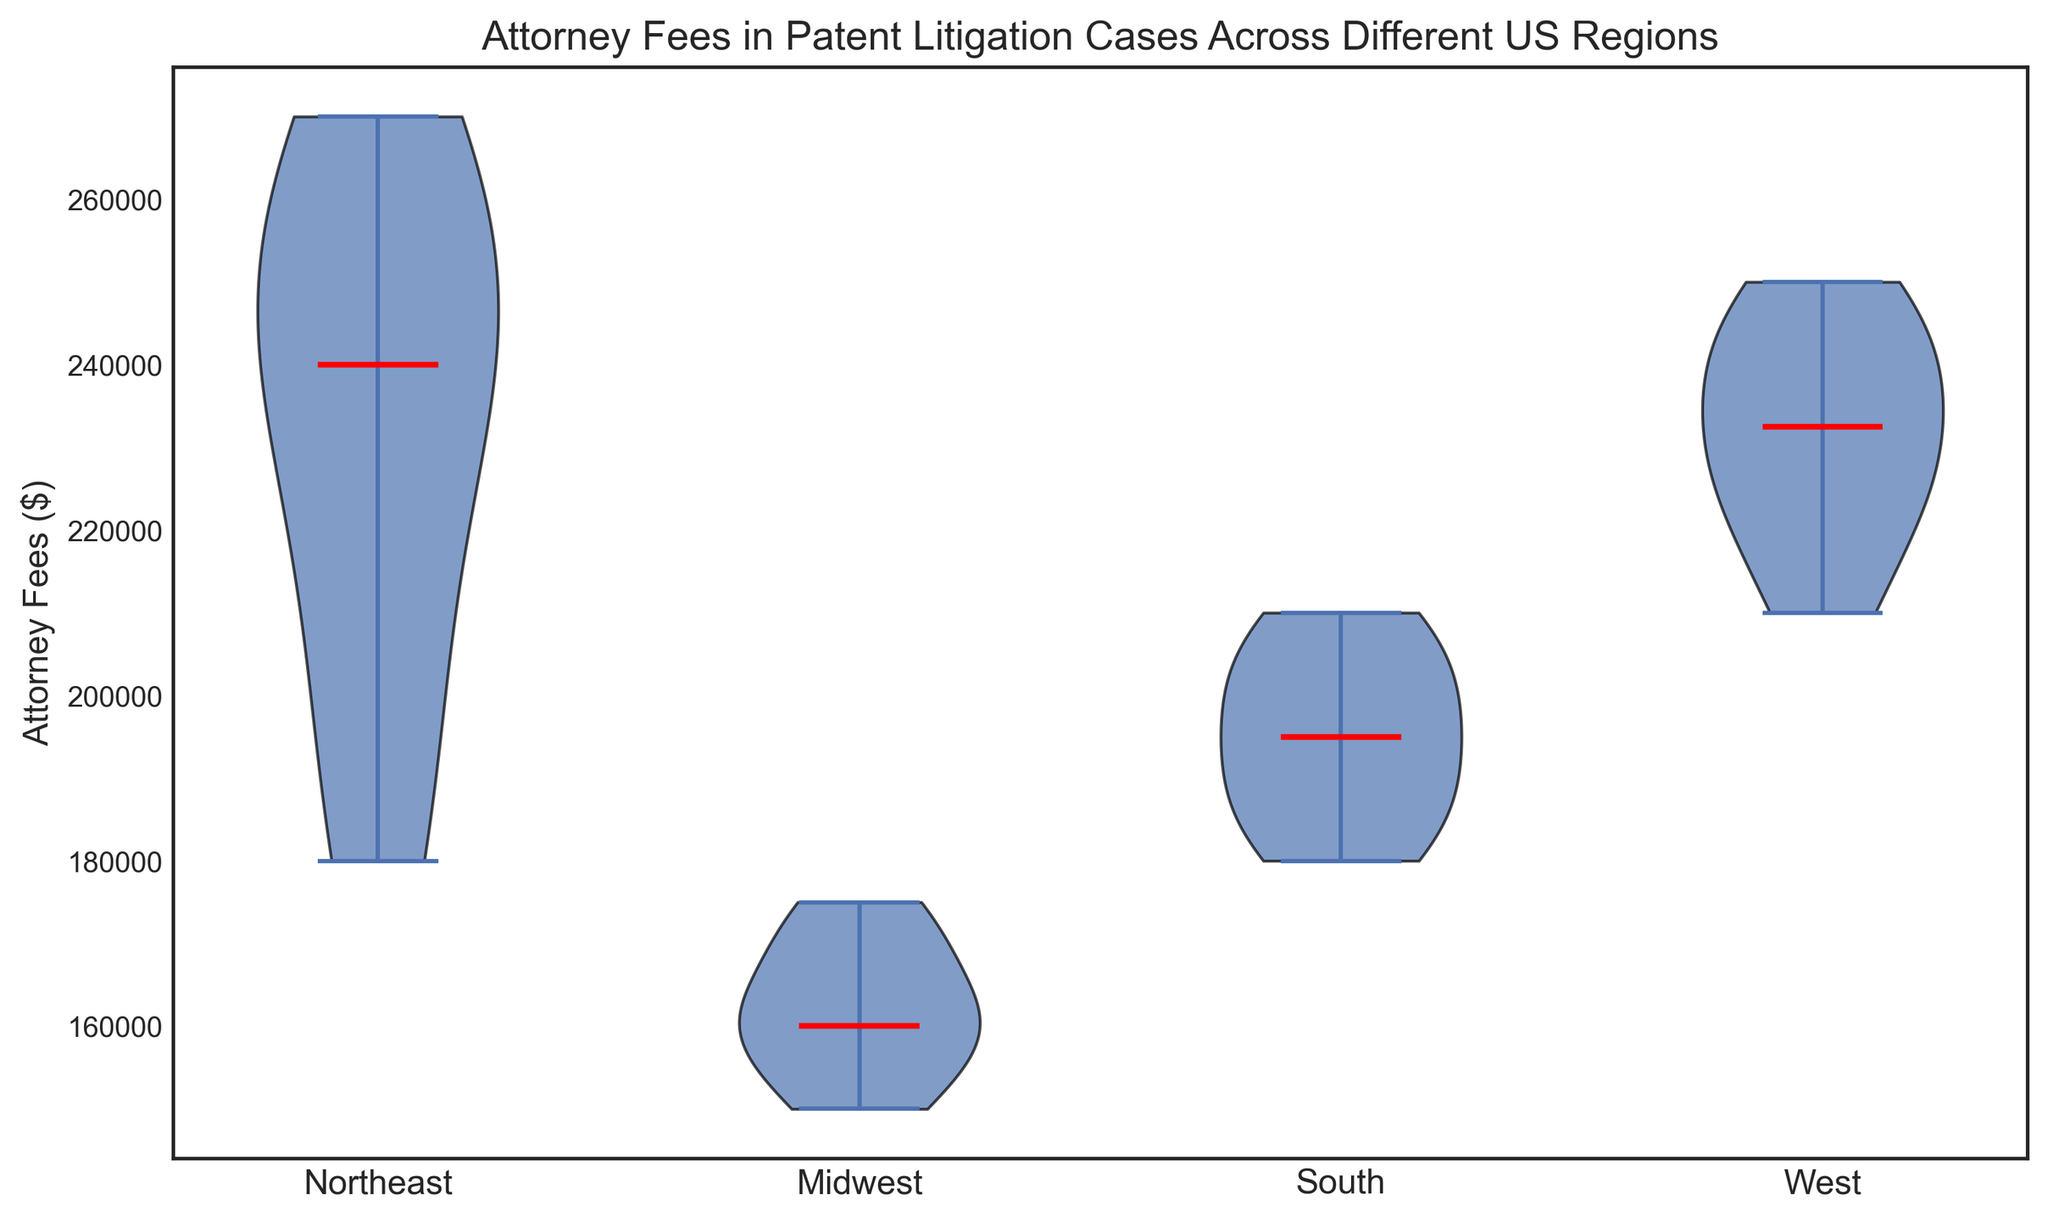What's the median attorney fee in the Midwest region? The median is indicated by a red line in the violin plot. Look at the violin corresponding to the Midwest region.
Answer: 165,000 Which region has the highest median attorney fee? Compare the height of the red lines indicating median values across all regions. The West region has the highest median value.
Answer: West How do the distributions of attorney fees in the Northeast and South regions compare? Observe the shapes and spread of the violins. The Northeast has a wider spread and higher overall distribution compared to the South region.
Answer: Northeast has higher and wider distribution Is the median attorney fee higher in the Northeast or the Midwest? Compare the red lines indicating the median values for the Northeast and Midwest regions. The Northeast has a higher median than the Midwest.
Answer: Northeast What is the range of the distribution of attorney fees in the South region? The range can be identified by looking at the upper and lower limits of the violin in the South region. The distribution spans from approximately 180,000 to 210,000.
Answer: 180,000 to 210,000 Which region shows the smallest variation in attorney fees? The smallest variation is shown by the narrowest and shortest violin plot. The Midwest region has the smallest variation.
Answer: Midwest What is the approximate interquartile range (IQR) of attorney fees in the West region? The IQR is represented by the width at the middle part of the violin. For the West region, the IQR spans from approximately 220,000 to 245,000.
Answer: 25,000 How does the median attorney fee in the West region compare to the Northeast region? Compare the heights of the red lines indicating the median values for the West and Northeast regions. The West region has a higher median than the Northeast region.
Answer: West What can you infer about the spread of attorney fees in the Northeast and Midwest regions? The spread of the fees is represented by the height and width of the violins. The Northeast has a higher and wider spread, indicating more variability, while the Midwest has a narrow spread.
Answer: Northeast has more variability Based on the visual, which region is likely to have the least amount of high-end outliers in attorney fees? Outliers would stretch the violins' tails. The Midwest region has the least stretched tails, suggesting fewer high-end outliers.
Answer: Midwest 